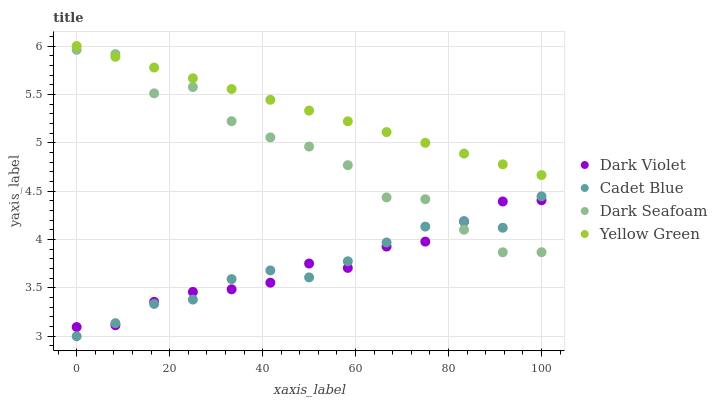Does Cadet Blue have the minimum area under the curve?
Answer yes or no. Yes. Does Yellow Green have the maximum area under the curve?
Answer yes or no. Yes. Does Yellow Green have the minimum area under the curve?
Answer yes or no. No. Does Cadet Blue have the maximum area under the curve?
Answer yes or no. No. Is Yellow Green the smoothest?
Answer yes or no. Yes. Is Dark Seafoam the roughest?
Answer yes or no. Yes. Is Cadet Blue the smoothest?
Answer yes or no. No. Is Cadet Blue the roughest?
Answer yes or no. No. Does Cadet Blue have the lowest value?
Answer yes or no. Yes. Does Yellow Green have the lowest value?
Answer yes or no. No. Does Yellow Green have the highest value?
Answer yes or no. Yes. Does Cadet Blue have the highest value?
Answer yes or no. No. Is Dark Violet less than Yellow Green?
Answer yes or no. Yes. Is Yellow Green greater than Cadet Blue?
Answer yes or no. Yes. Does Dark Seafoam intersect Yellow Green?
Answer yes or no. Yes. Is Dark Seafoam less than Yellow Green?
Answer yes or no. No. Is Dark Seafoam greater than Yellow Green?
Answer yes or no. No. Does Dark Violet intersect Yellow Green?
Answer yes or no. No. 